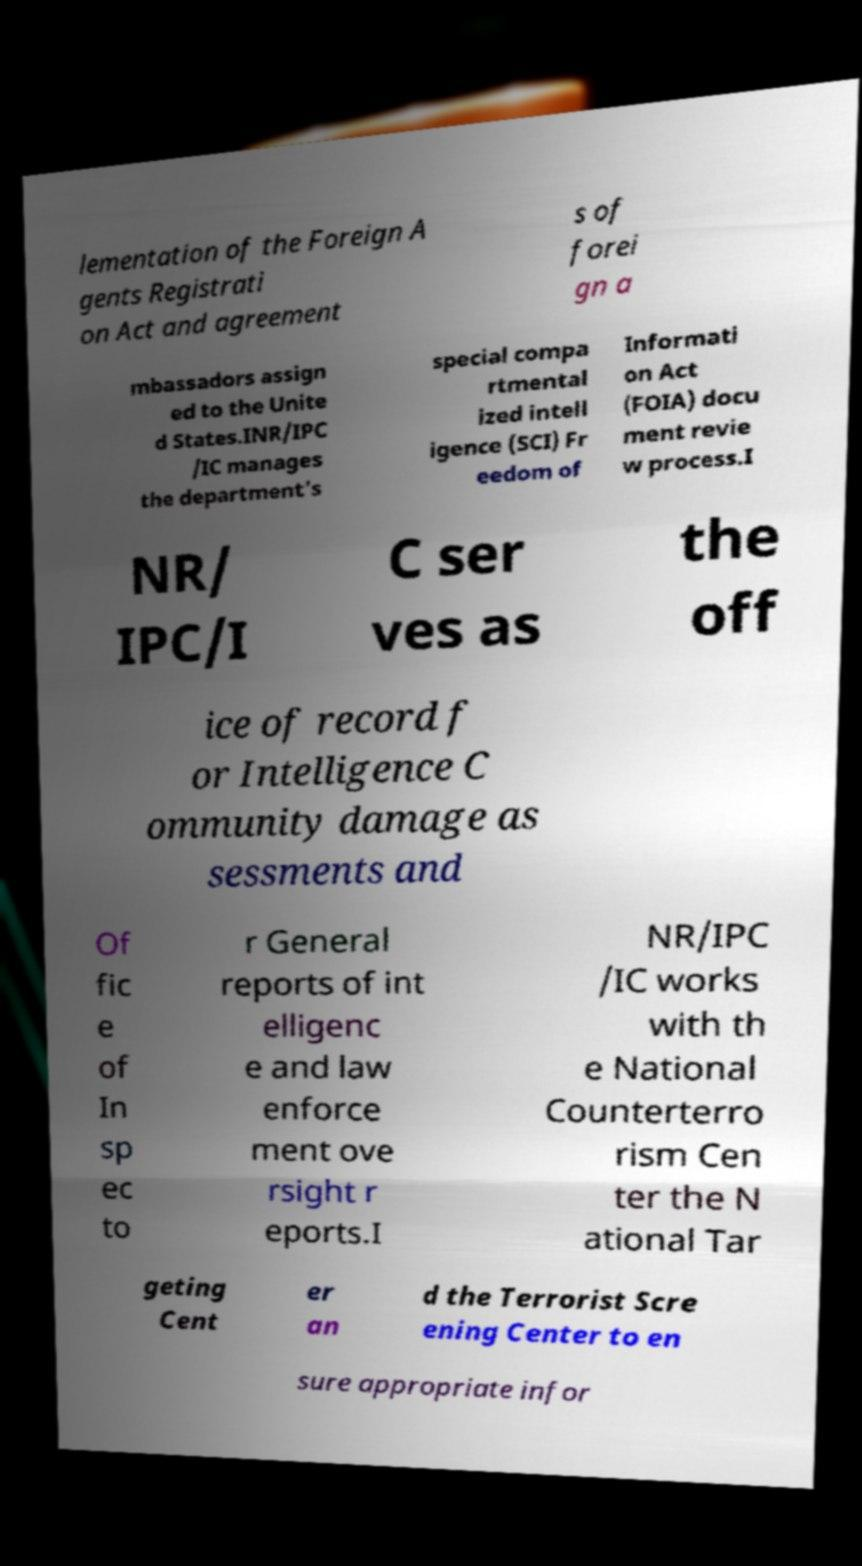Please read and relay the text visible in this image. What does it say? lementation of the Foreign A gents Registrati on Act and agreement s of forei gn a mbassadors assign ed to the Unite d States.INR/IPC /IC manages the department’s special compa rtmental ized intell igence (SCI) Fr eedom of Informati on Act (FOIA) docu ment revie w process.I NR/ IPC/I C ser ves as the off ice of record f or Intelligence C ommunity damage as sessments and Of fic e of In sp ec to r General reports of int elligenc e and law enforce ment ove rsight r eports.I NR/IPC /IC works with th e National Counterterro rism Cen ter the N ational Tar geting Cent er an d the Terrorist Scre ening Center to en sure appropriate infor 